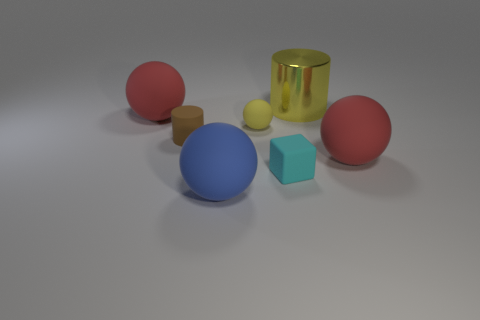Add 3 cyan metallic cylinders. How many objects exist? 10 Subtract all blocks. How many objects are left? 6 Add 3 tiny matte things. How many tiny matte things are left? 6 Add 2 small blue shiny cylinders. How many small blue shiny cylinders exist? 2 Subtract 1 yellow spheres. How many objects are left? 6 Subtract all large red metallic blocks. Subtract all yellow rubber things. How many objects are left? 6 